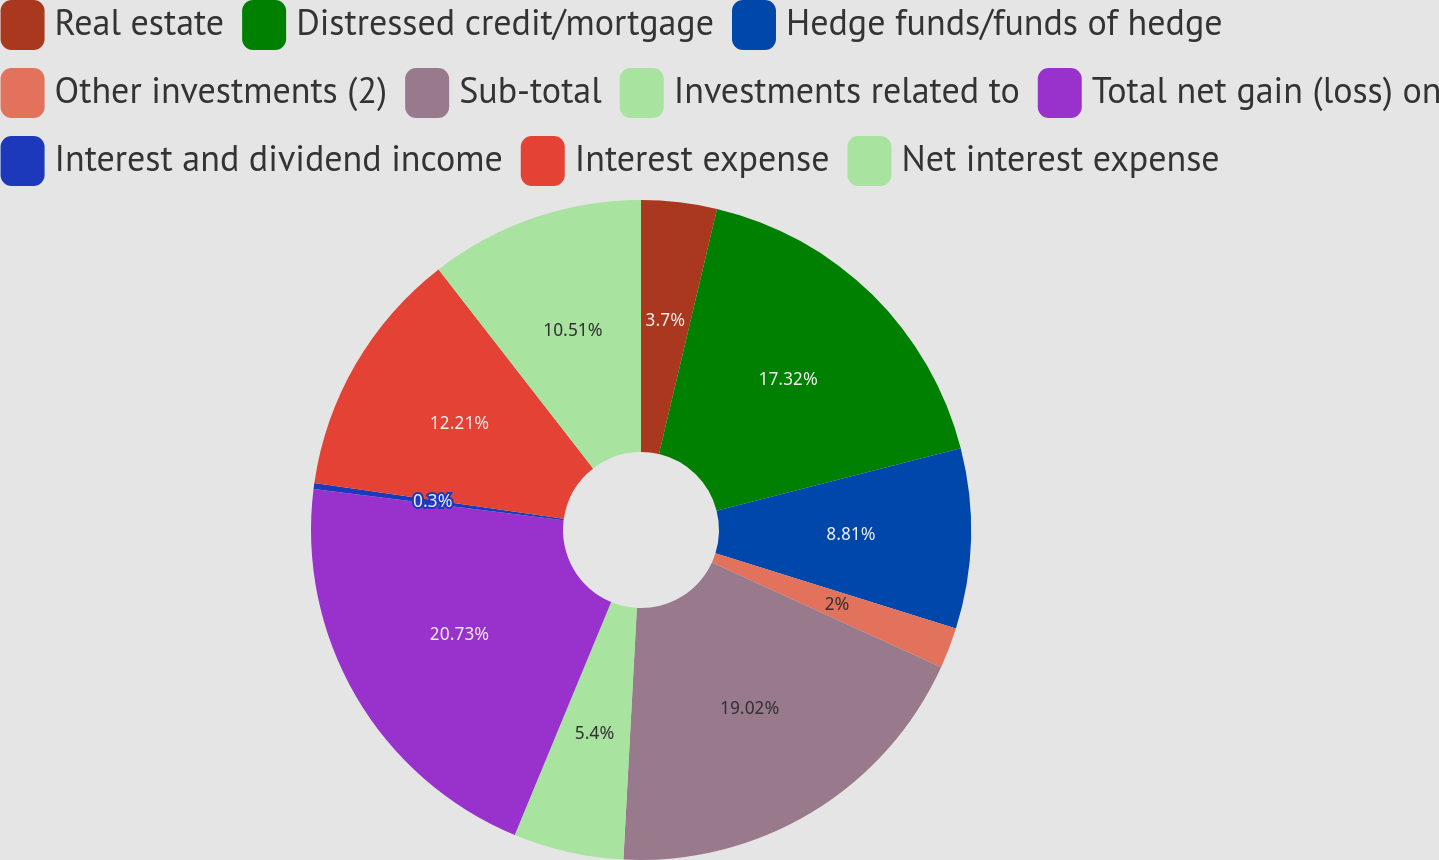Convert chart. <chart><loc_0><loc_0><loc_500><loc_500><pie_chart><fcel>Real estate<fcel>Distressed credit/mortgage<fcel>Hedge funds/funds of hedge<fcel>Other investments (2)<fcel>Sub-total<fcel>Investments related to<fcel>Total net gain (loss) on<fcel>Interest and dividend income<fcel>Interest expense<fcel>Net interest expense<nl><fcel>3.7%<fcel>17.32%<fcel>8.81%<fcel>2.0%<fcel>19.02%<fcel>5.4%<fcel>20.73%<fcel>0.3%<fcel>12.21%<fcel>10.51%<nl></chart> 